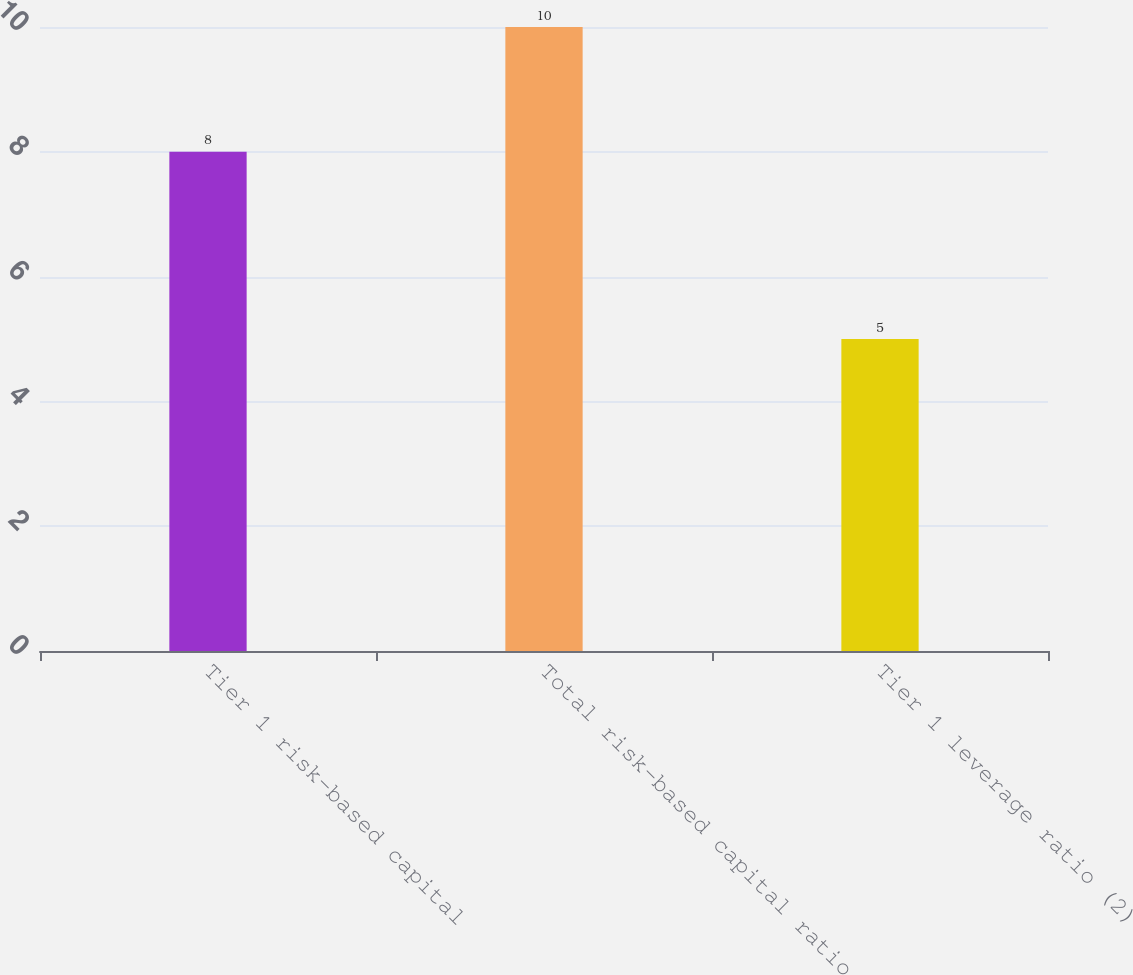Convert chart. <chart><loc_0><loc_0><loc_500><loc_500><bar_chart><fcel>Tier 1 risk-based capital<fcel>Total risk-based capital ratio<fcel>Tier 1 leverage ratio (2)<nl><fcel>8<fcel>10<fcel>5<nl></chart> 